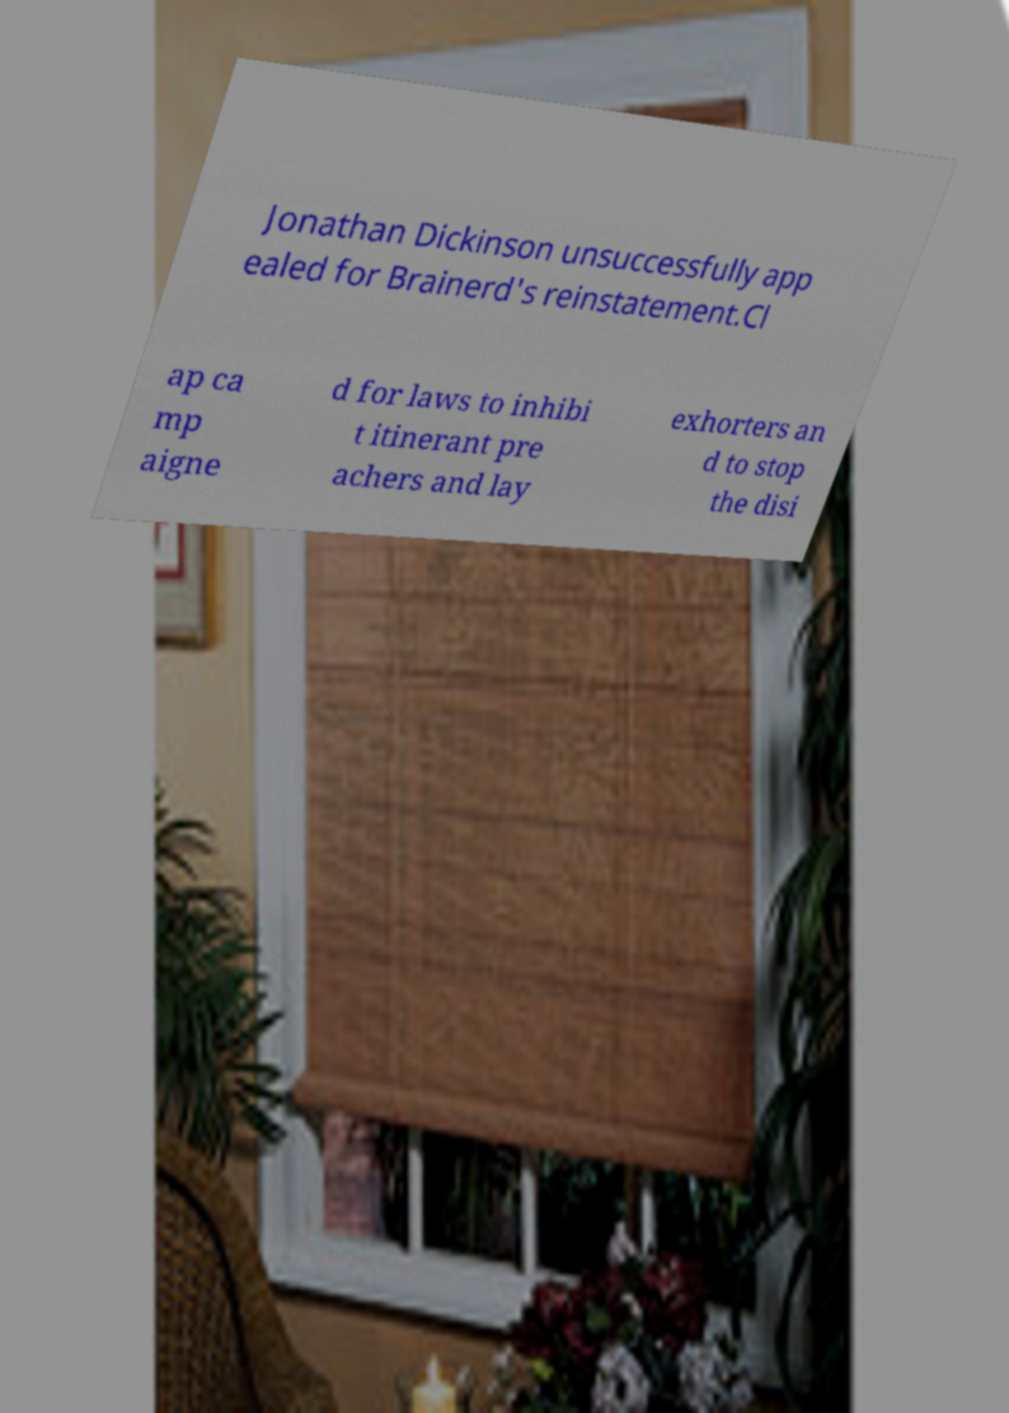Could you assist in decoding the text presented in this image and type it out clearly? Jonathan Dickinson unsuccessfully app ealed for Brainerd's reinstatement.Cl ap ca mp aigne d for laws to inhibi t itinerant pre achers and lay exhorters an d to stop the disi 